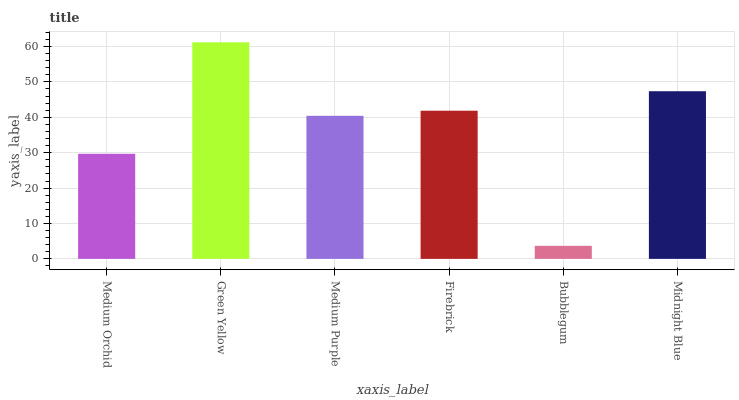Is Medium Purple the minimum?
Answer yes or no. No. Is Medium Purple the maximum?
Answer yes or no. No. Is Green Yellow greater than Medium Purple?
Answer yes or no. Yes. Is Medium Purple less than Green Yellow?
Answer yes or no. Yes. Is Medium Purple greater than Green Yellow?
Answer yes or no. No. Is Green Yellow less than Medium Purple?
Answer yes or no. No. Is Firebrick the high median?
Answer yes or no. Yes. Is Medium Purple the low median?
Answer yes or no. Yes. Is Green Yellow the high median?
Answer yes or no. No. Is Bubblegum the low median?
Answer yes or no. No. 